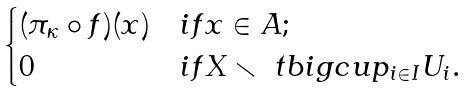<formula> <loc_0><loc_0><loc_500><loc_500>\begin{cases} ( \pi _ { \kappa } \circ f ) ( x ) & i f x \in A ; \\ 0 & i f X \smallsetminus \ t b i g c u p _ { i \in I } U _ { i } . \end{cases}</formula> 